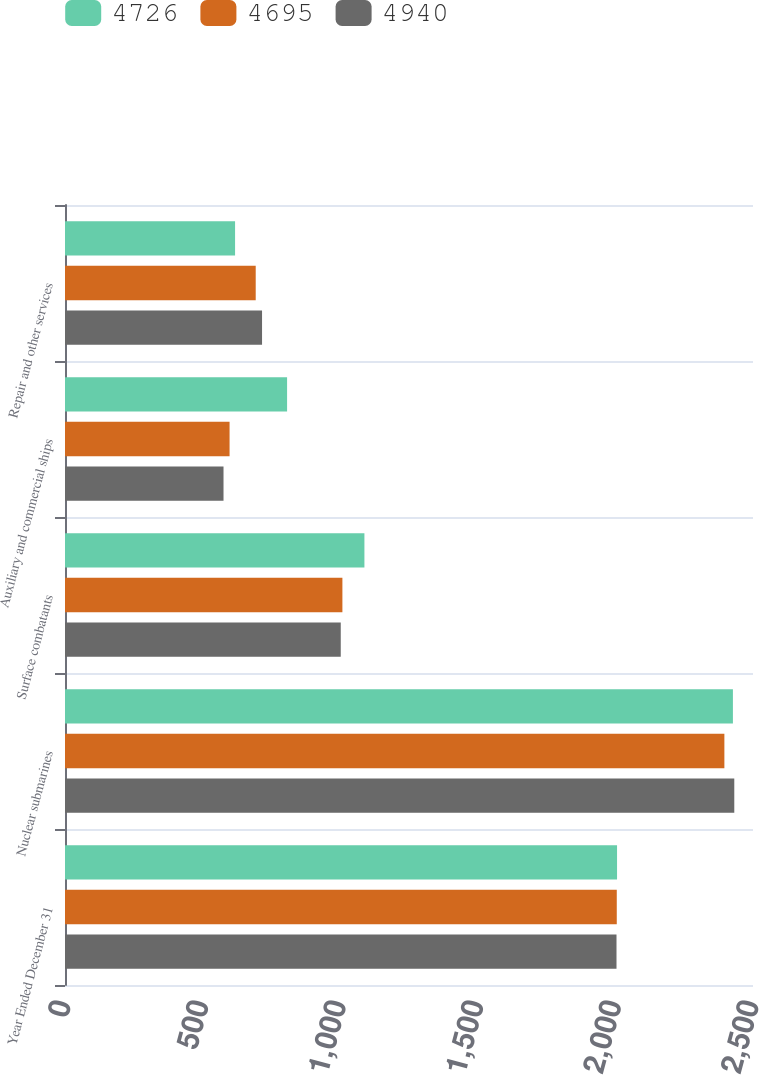Convert chart to OTSL. <chart><loc_0><loc_0><loc_500><loc_500><stacked_bar_chart><ecel><fcel>Year Ended December 31<fcel>Nuclear submarines<fcel>Surface combatants<fcel>Auxiliary and commercial ships<fcel>Repair and other services<nl><fcel>4726<fcel>2006<fcel>2427<fcel>1088<fcel>807<fcel>618<nl><fcel>4695<fcel>2005<fcel>2396<fcel>1008<fcel>598<fcel>693<nl><fcel>4940<fcel>2004<fcel>2432<fcel>1002<fcel>576<fcel>716<nl></chart> 